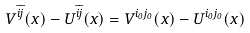<formula> <loc_0><loc_0><loc_500><loc_500>V ^ { \bar { i } \bar { j } } ( x ) - U ^ { \bar { i } \bar { j } } ( x ) = V ^ { i _ { 0 } j _ { 0 } } ( x ) - U ^ { i _ { 0 } j _ { 0 } } ( x )</formula> 